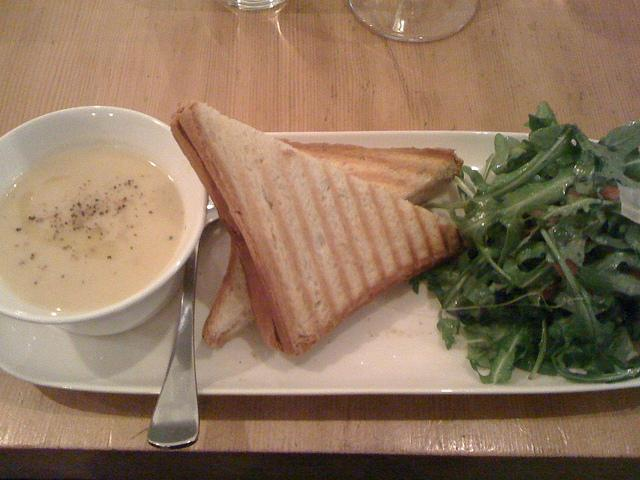Which of the objects on the plate is inedible?

Choices:
A) soup
B) vegetables
C) bread
D) utensil utensil 